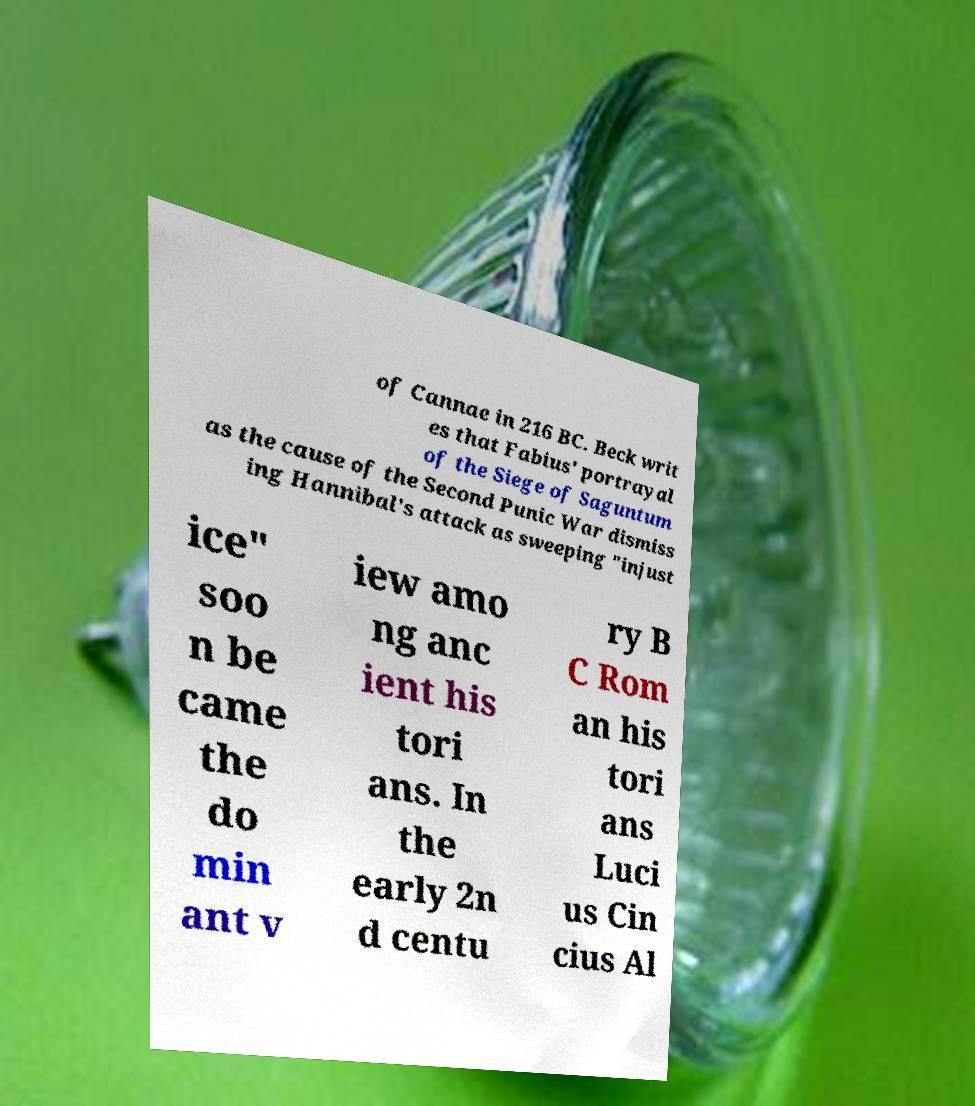Could you extract and type out the text from this image? of Cannae in 216 BC. Beck writ es that Fabius' portrayal of the Siege of Saguntum as the cause of the Second Punic War dismiss ing Hannibal's attack as sweeping "injust ice" soo n be came the do min ant v iew amo ng anc ient his tori ans. In the early 2n d centu ry B C Rom an his tori ans Luci us Cin cius Al 